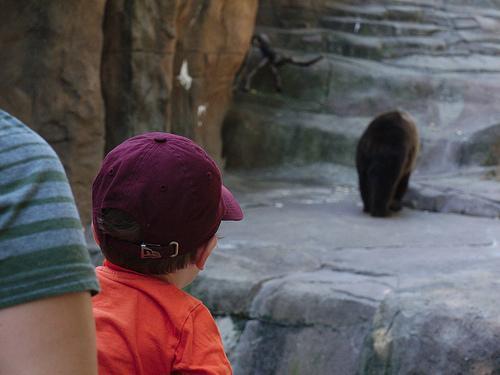How many bears are there?
Give a very brief answer. 1. 